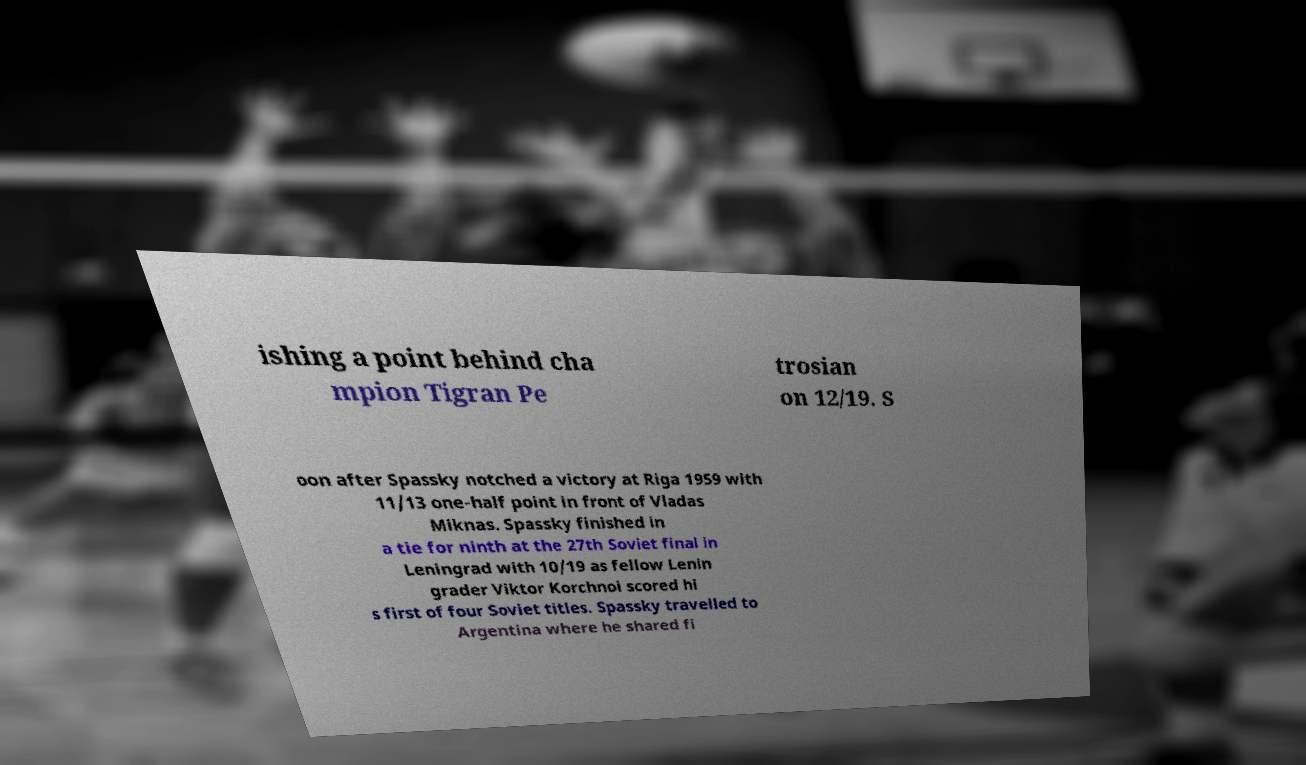What messages or text are displayed in this image? I need them in a readable, typed format. ishing a point behind cha mpion Tigran Pe trosian on 12/19. S oon after Spassky notched a victory at Riga 1959 with 11/13 one-half point in front of Vladas Miknas. Spassky finished in a tie for ninth at the 27th Soviet final in Leningrad with 10/19 as fellow Lenin grader Viktor Korchnoi scored hi s first of four Soviet titles. Spassky travelled to Argentina where he shared fi 